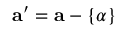<formula> <loc_0><loc_0><loc_500><loc_500>a ^ { \prime } = a - \{ \alpha \}</formula> 